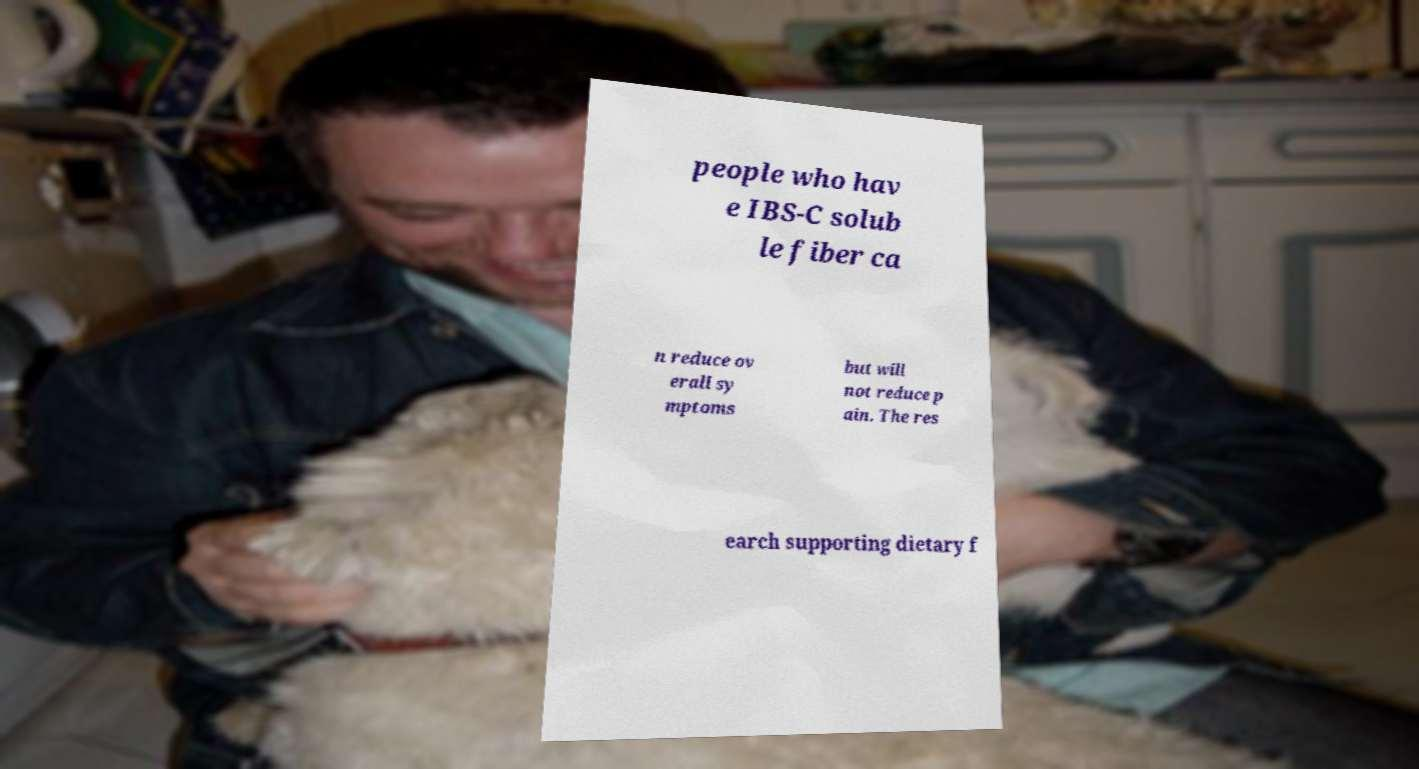Could you assist in decoding the text presented in this image and type it out clearly? people who hav e IBS-C solub le fiber ca n reduce ov erall sy mptoms but will not reduce p ain. The res earch supporting dietary f 